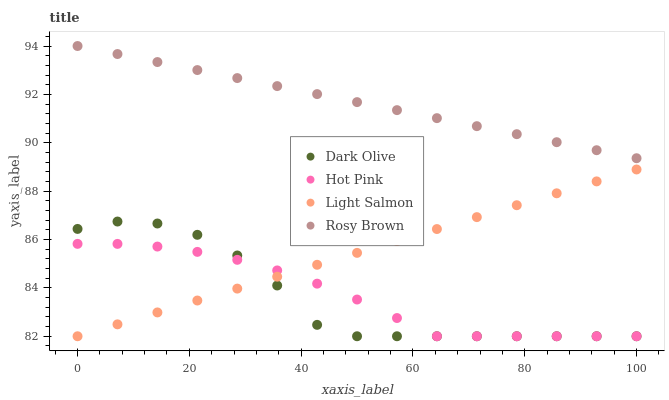Does Dark Olive have the minimum area under the curve?
Answer yes or no. Yes. Does Rosy Brown have the maximum area under the curve?
Answer yes or no. Yes. Does Rosy Brown have the minimum area under the curve?
Answer yes or no. No. Does Dark Olive have the maximum area under the curve?
Answer yes or no. No. Is Light Salmon the smoothest?
Answer yes or no. Yes. Is Dark Olive the roughest?
Answer yes or no. Yes. Is Rosy Brown the smoothest?
Answer yes or no. No. Is Rosy Brown the roughest?
Answer yes or no. No. Does Light Salmon have the lowest value?
Answer yes or no. Yes. Does Rosy Brown have the lowest value?
Answer yes or no. No. Does Rosy Brown have the highest value?
Answer yes or no. Yes. Does Dark Olive have the highest value?
Answer yes or no. No. Is Light Salmon less than Rosy Brown?
Answer yes or no. Yes. Is Rosy Brown greater than Light Salmon?
Answer yes or no. Yes. Does Light Salmon intersect Hot Pink?
Answer yes or no. Yes. Is Light Salmon less than Hot Pink?
Answer yes or no. No. Is Light Salmon greater than Hot Pink?
Answer yes or no. No. Does Light Salmon intersect Rosy Brown?
Answer yes or no. No. 